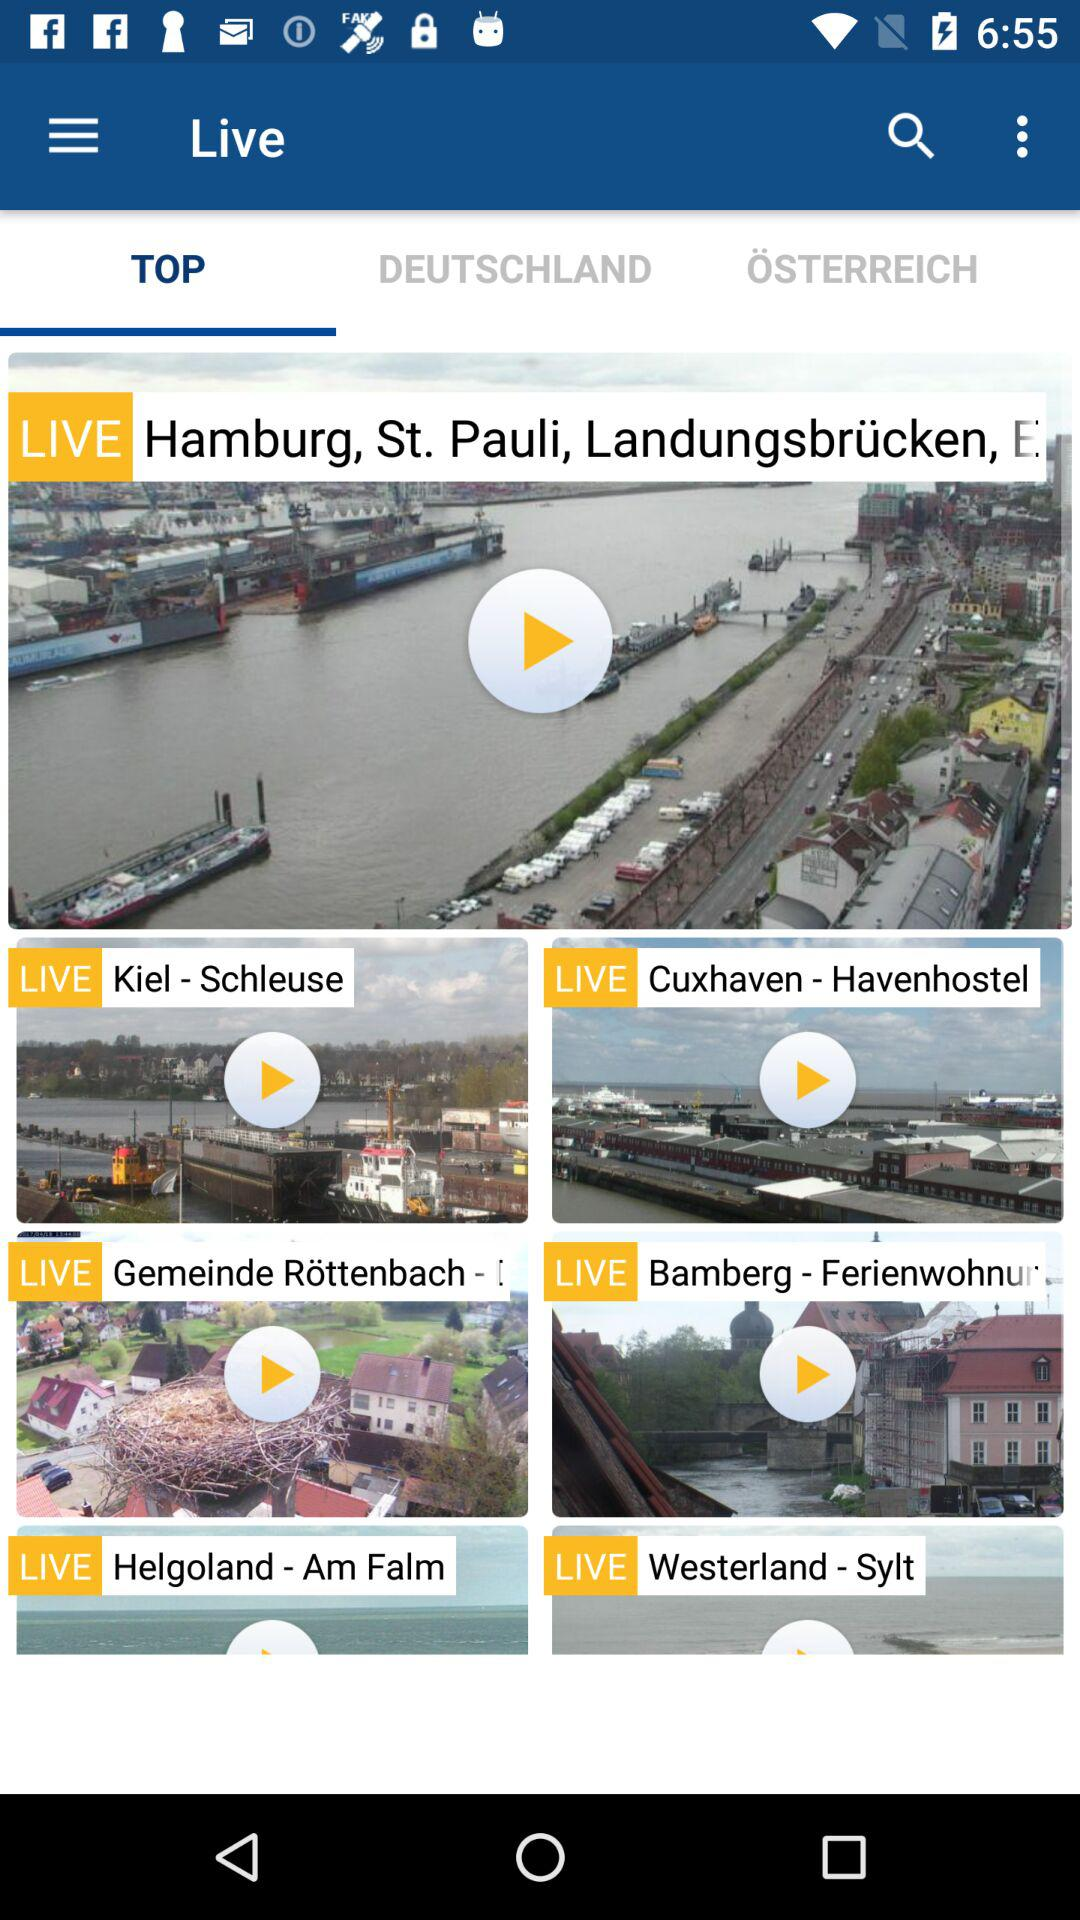Which tab has been selected? The tab that has been selected is "TOP". 